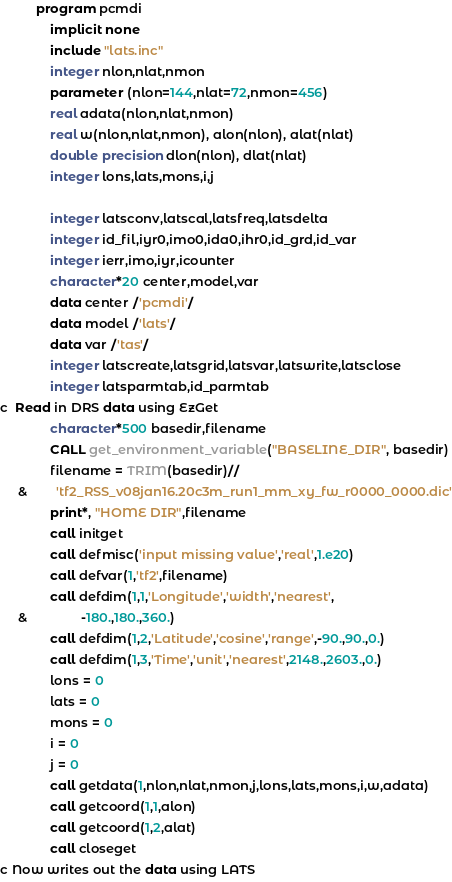<code> <loc_0><loc_0><loc_500><loc_500><_FORTRAN_>          program pcmdi
              implicit none
              include "lats.inc"
              integer nlon,nlat,nmon
              parameter (nlon=144,nlat=72,nmon=456)
              real adata(nlon,nlat,nmon)
              real w(nlon,nlat,nmon), alon(nlon), alat(nlat)
              double precision dlon(nlon), dlat(nlat)
              integer lons,lats,mons,i,j

              integer latsconv,latscal,latsfreq,latsdelta
              integer id_fil,iyr0,imo0,ida0,ihr0,id_grd,id_var
              integer ierr,imo,iyr,icounter
              character*20 center,model,var
              data center /'pcmdi'/
              data model /'lats'/
              data var /'tas'/
              integer latscreate,latsgrid,latsvar,latswrite,latsclose
              integer latsparmtab,id_parmtab
c  Read in DRS data using EzGet
              character*500 basedir,filename
              CALL get_environment_variable("BASELINE_DIR", basedir)
              filename = TRIM(basedir)//
     &        'tf2_RSS_v08jan16.20c3m_run1_mm_xy_fw_r0000_0000.dic'
              print*, "HOME DIR",filename
              call initget
              call defmisc('input missing value','real',1.e20)
              call defvar(1,'tf2',filename)
              call defdim(1,1,'Longitude','width','nearest',
     &               -180.,180.,360.)
              call defdim(1,2,'Latitude','cosine','range',-90.,90.,0.)
              call defdim(1,3,'Time','unit','nearest',2148.,2603.,0.)
              lons = 0
              lats = 0
              mons = 0
              i = 0
              j = 0
              call getdata(1,nlon,nlat,nmon,j,lons,lats,mons,i,w,adata)
              call getcoord(1,1,alon)
              call getcoord(1,2,alat)
              call closeget
c Now writes out the data using LATS
</code> 